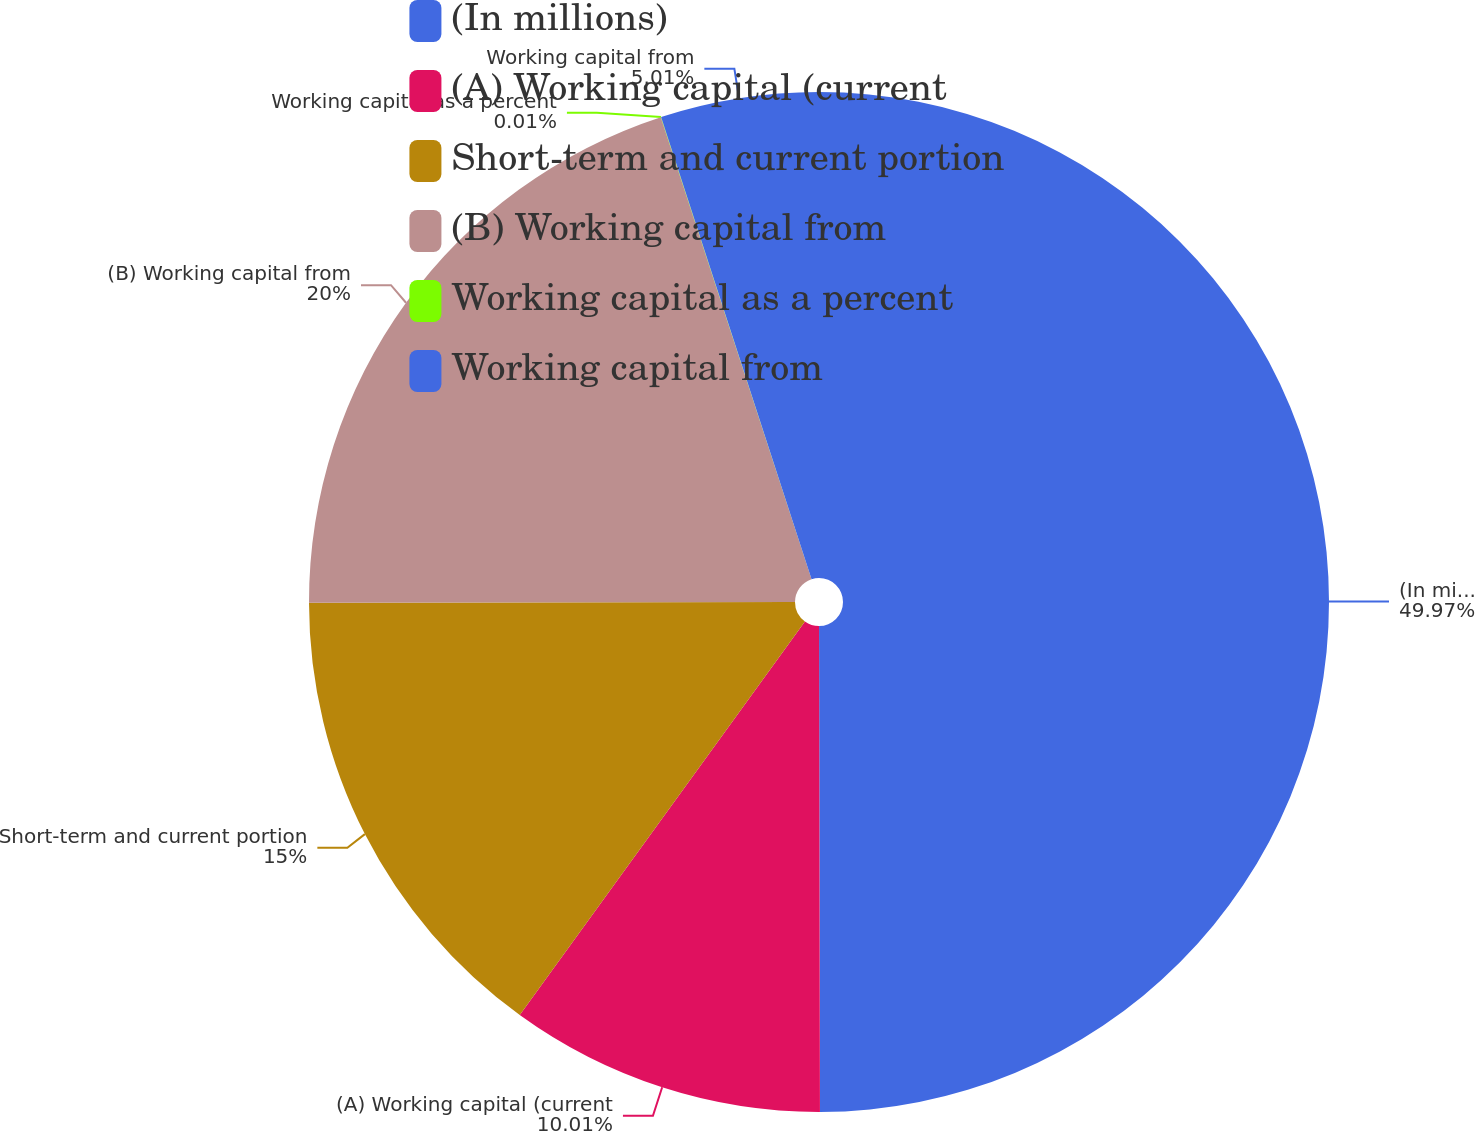<chart> <loc_0><loc_0><loc_500><loc_500><pie_chart><fcel>(In millions)<fcel>(A) Working capital (current<fcel>Short-term and current portion<fcel>(B) Working capital from<fcel>Working capital as a percent<fcel>Working capital from<nl><fcel>49.97%<fcel>10.01%<fcel>15.0%<fcel>20.0%<fcel>0.01%<fcel>5.01%<nl></chart> 